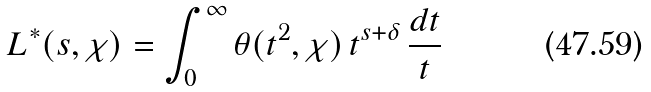<formula> <loc_0><loc_0><loc_500><loc_500>L ^ { \ast } ( s , \chi ) = \int _ { 0 } ^ { \infty } \theta ( t ^ { 2 } , \chi ) \, t ^ { s + \delta } \, \frac { d t } { t }</formula> 